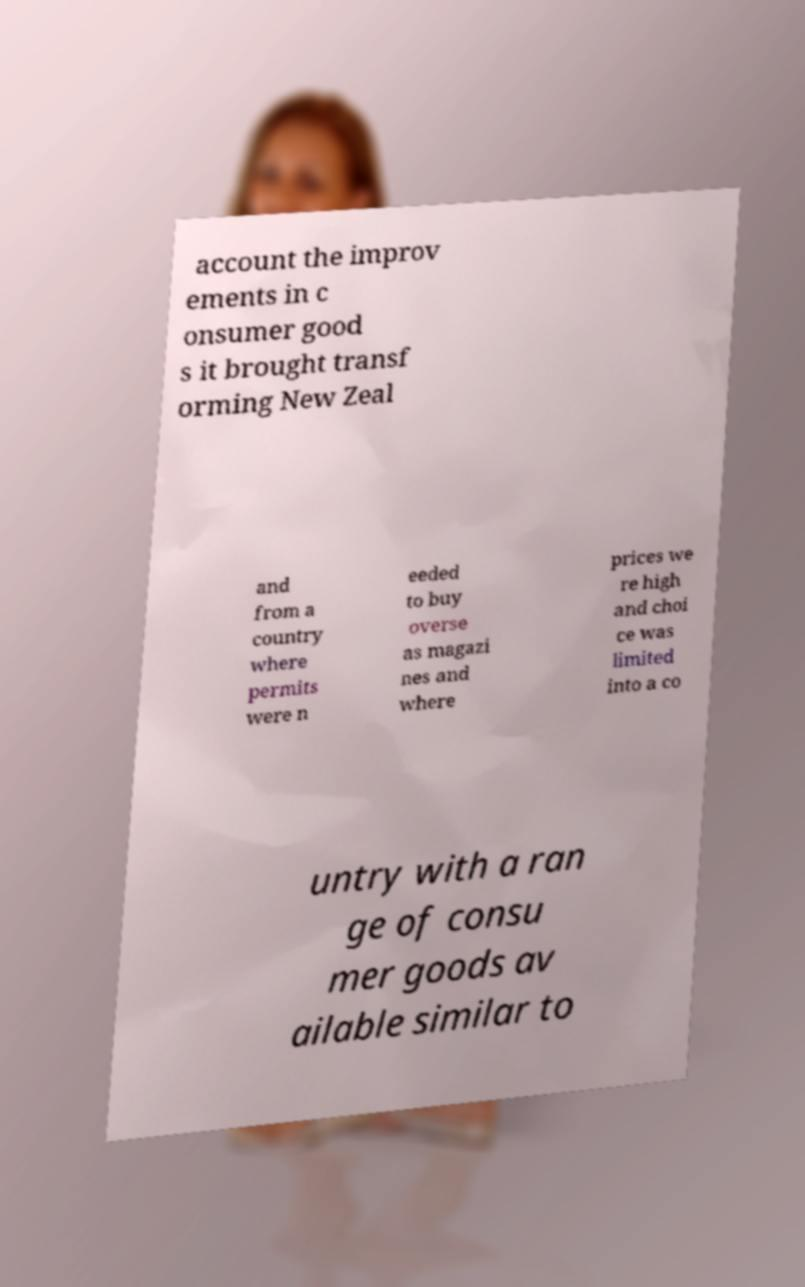Could you extract and type out the text from this image? account the improv ements in c onsumer good s it brought transf orming New Zeal and from a country where permits were n eeded to buy overse as magazi nes and where prices we re high and choi ce was limited into a co untry with a ran ge of consu mer goods av ailable similar to 